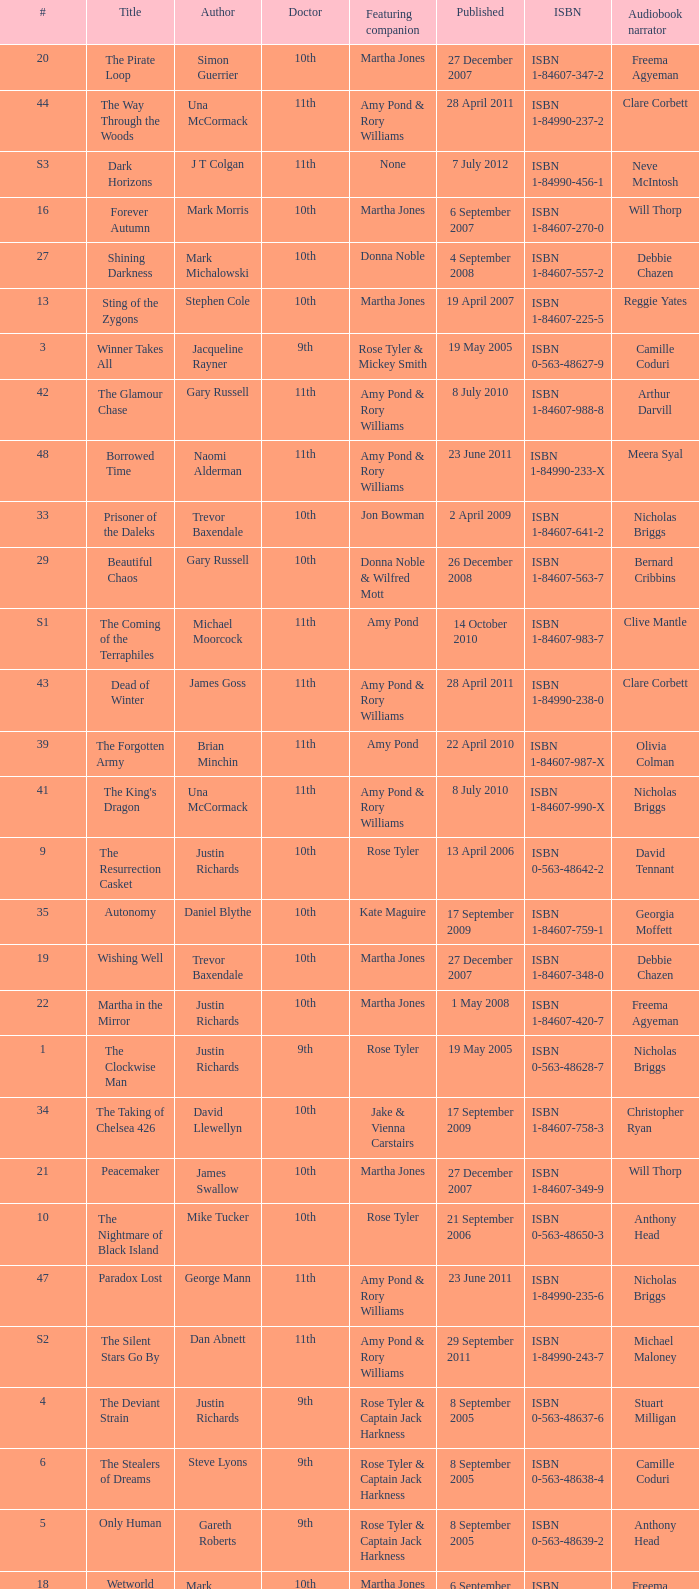What is the title of book number 7? The Stone Rose. 